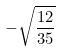<formula> <loc_0><loc_0><loc_500><loc_500>- \sqrt { \frac { 1 2 } { 3 5 } }</formula> 